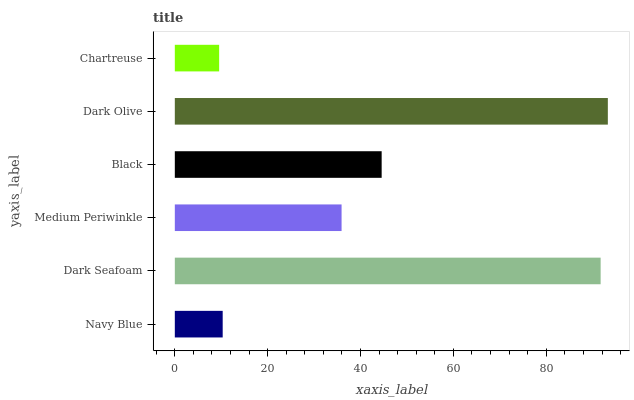Is Chartreuse the minimum?
Answer yes or no. Yes. Is Dark Olive the maximum?
Answer yes or no. Yes. Is Dark Seafoam the minimum?
Answer yes or no. No. Is Dark Seafoam the maximum?
Answer yes or no. No. Is Dark Seafoam greater than Navy Blue?
Answer yes or no. Yes. Is Navy Blue less than Dark Seafoam?
Answer yes or no. Yes. Is Navy Blue greater than Dark Seafoam?
Answer yes or no. No. Is Dark Seafoam less than Navy Blue?
Answer yes or no. No. Is Black the high median?
Answer yes or no. Yes. Is Medium Periwinkle the low median?
Answer yes or no. Yes. Is Dark Seafoam the high median?
Answer yes or no. No. Is Dark Seafoam the low median?
Answer yes or no. No. 